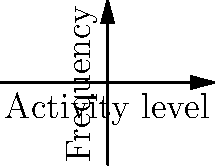Based on the brain activity distribution graph shown above, which represents data from fMRI scans, what key difference can be observed between the control group and the group with depression? How might this inform diagnosis and treatment approaches? To analyze this graph and understand its implications for diagnosis and treatment of depression, let's follow these steps:

1. Observe the distributions:
   - The blue line represents the control group (mentally healthy individuals).
   - The red line represents the group with depression.

2. Compare the peaks:
   - The control group's peak is slightly to the left of center.
   - The depression group's peak is slightly to the right of center.

3. Interpret the x-axis (Activity level):
   - Higher values indicate increased brain activity.
   - Lower values indicate decreased brain activity.

4. Key difference:
   - The depression group shows a shift towards higher activity levels compared to the control group.
   - This suggests that individuals with depression may have increased brain activity in certain regions.

5. Implications for diagnosis:
   - fMRI scans showing this pattern of increased activity could be an indicator of depression.
   - However, it's important to note that this should be used in conjunction with other diagnostic criteria, not as a sole determinant.

6. Implications for treatment:
   - Treatments that aim to modulate this increased brain activity might be effective.
   - This could include targeted therapies such as Transcranial Magnetic Stimulation (TMS) or certain medications that affect neurotransmitter levels.

7. Further considerations:
   - The specific brain regions showing increased activity are not specified in this graph but would be crucial in real-world applications.
   - Individual variations should always be considered, as not all patients with depression may show this exact pattern.
Answer: Increased brain activity in depression group; informs potential for activity-modulating treatments. 